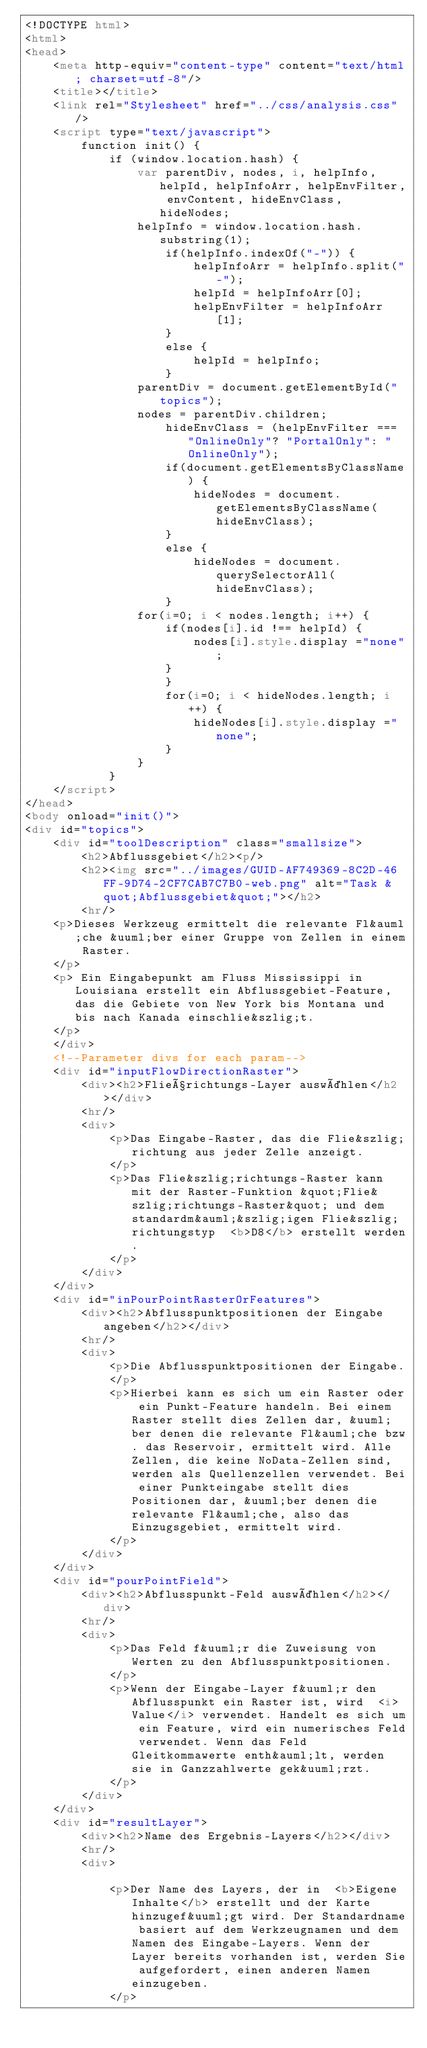<code> <loc_0><loc_0><loc_500><loc_500><_HTML_><!DOCTYPE html>
<html>
<head>
    <meta http-equiv="content-type" content="text/html; charset=utf-8"/>
    <title></title>
    <link rel="Stylesheet" href="../css/analysis.css" />
    <script type="text/javascript">
        function init() {
            if (window.location.hash) {
                var parentDiv, nodes, i, helpInfo, helpId, helpInfoArr, helpEnvFilter, envContent, hideEnvClass, hideNodes;
                helpInfo = window.location.hash.substring(1);
                    if(helpInfo.indexOf("-")) {
                        helpInfoArr = helpInfo.split("-");
                        helpId = helpInfoArr[0];
                        helpEnvFilter = helpInfoArr[1];
                    }
                    else {
                        helpId = helpInfo;
                    }
                parentDiv = document.getElementById("topics");
                nodes = parentDiv.children;
                    hideEnvClass = (helpEnvFilter === "OnlineOnly"? "PortalOnly": "OnlineOnly");
                    if(document.getElementsByClassName) {
                        hideNodes = document.getElementsByClassName(hideEnvClass);
                    }
                    else {
                        hideNodes = document.querySelectorAll(hideEnvClass);
                    }
                for(i=0; i < nodes.length; i++) {
                    if(nodes[i].id !== helpId) {
                        nodes[i].style.display ="none";
                    }
                    }
                    for(i=0; i < hideNodes.length; i++) {
                        hideNodes[i].style.display ="none";
                    }
                }
            }
    </script>
</head>
<body onload="init()">
<div id="topics">
    <div id="toolDescription" class="smallsize">
        <h2>Abflussgebiet</h2><p/>
        <h2><img src="../images/GUID-AF749369-8C2D-46FF-9D74-2CF7CAB7C7B0-web.png" alt="Task &quot;Abflussgebiet&quot;"></h2>
        <hr/>
    <p>Dieses Werkzeug ermittelt die relevante Fl&auml;che &uuml;ber einer Gruppe von Zellen in einem Raster.
    </p>
    <p> Ein Eingabepunkt am Fluss Mississippi in Louisiana erstellt ein Abflussgebiet-Feature, das die Gebiete von New York bis Montana und bis nach Kanada einschlie&szlig;t.
    </p>
    </div>
    <!--Parameter divs for each param-->
    <div id="inputFlowDirectionRaster">
        <div><h2>Fließrichtungs-Layer auswählen</h2></div>
        <hr/>
        <div>
            <p>Das Eingabe-Raster, das die Flie&szlig;richtung aus jeder Zelle anzeigt.
            </p>
            <p>Das Flie&szlig;richtungs-Raster kann mit der Raster-Funktion &quot;Flie&szlig;richtungs-Raster&quot; und dem standardm&auml;&szlig;igen Flie&szlig;richtungstyp  <b>D8</b> erstellt werden.
            </p>
        </div>
    </div>
    <div id="inPourPointRasterOrFeatures">
        <div><h2>Abflusspunktpositionen der Eingabe angeben</h2></div>
        <hr/>
        <div>
            <p>Die Abflusspunktpositionen der Eingabe.
            </p>
            <p>Hierbei kann es sich um ein Raster oder ein Punkt-Feature handeln. Bei einem Raster stellt dies Zellen dar, &uuml;ber denen die relevante Fl&auml;che bzw. das Reservoir, ermittelt wird. Alle Zellen, die keine NoData-Zellen sind, werden als Quellenzellen verwendet. Bei einer Punkteingabe stellt dies Positionen dar, &uuml;ber denen die relevante Fl&auml;che, also das Einzugsgebiet, ermittelt wird.
            </p>
        </div>
    </div>
    <div id="pourPointField">
        <div><h2>Abflusspunkt-Feld auswählen</h2></div>
        <hr/>
        <div>
            <p>Das Feld f&uuml;r die Zuweisung von Werten zu den Abflusspunktpositionen.
            </p>
            <p>Wenn der Eingabe-Layer f&uuml;r den Abflusspunkt ein Raster ist, wird  <i>Value</i> verwendet. Handelt es sich um ein Feature, wird ein numerisches Feld verwendet. Wenn das Feld Gleitkommawerte enth&auml;lt, werden sie in Ganzzahlwerte gek&uuml;rzt.
            </p>
        </div>
    </div>
    <div id="resultLayer">
        <div><h2>Name des Ergebnis-Layers</h2></div>
        <hr/>
        <div>
            
            <p>Der Name des Layers, der in  <b>Eigene Inhalte</b> erstellt und der Karte hinzugef&uuml;gt wird. Der Standardname basiert auf dem Werkzeugnamen und dem Namen des Eingabe-Layers. Wenn der Layer bereits vorhanden ist, werden Sie aufgefordert, einen anderen Namen einzugeben.
            </p></code> 